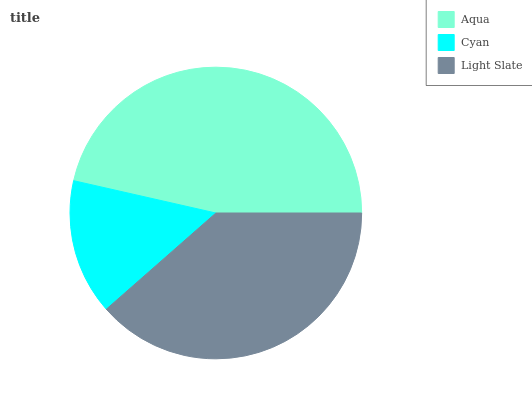Is Cyan the minimum?
Answer yes or no. Yes. Is Aqua the maximum?
Answer yes or no. Yes. Is Light Slate the minimum?
Answer yes or no. No. Is Light Slate the maximum?
Answer yes or no. No. Is Light Slate greater than Cyan?
Answer yes or no. Yes. Is Cyan less than Light Slate?
Answer yes or no. Yes. Is Cyan greater than Light Slate?
Answer yes or no. No. Is Light Slate less than Cyan?
Answer yes or no. No. Is Light Slate the high median?
Answer yes or no. Yes. Is Light Slate the low median?
Answer yes or no. Yes. Is Aqua the high median?
Answer yes or no. No. Is Aqua the low median?
Answer yes or no. No. 